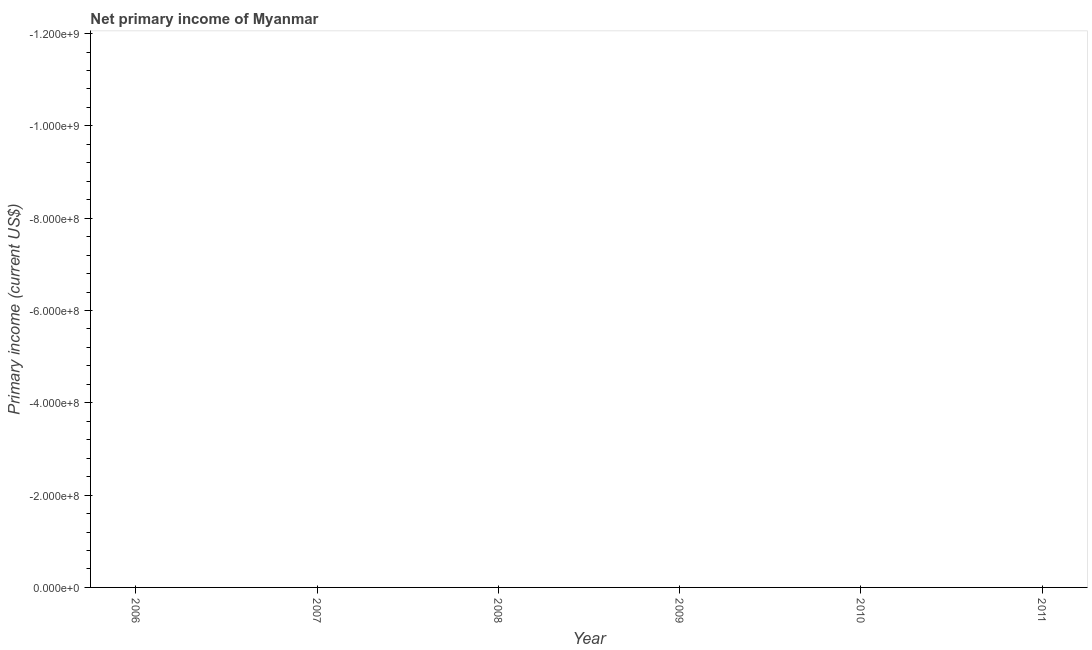What is the average amount of primary income per year?
Your answer should be compact. 0. What is the median amount of primary income?
Your answer should be compact. 0. In how many years, is the amount of primary income greater than -360000000 US$?
Provide a succinct answer. 0. In how many years, is the amount of primary income greater than the average amount of primary income taken over all years?
Provide a succinct answer. 0. Does the amount of primary income monotonically increase over the years?
Provide a succinct answer. No. How many lines are there?
Your answer should be compact. 0. Does the graph contain any zero values?
Give a very brief answer. Yes. What is the title of the graph?
Your response must be concise. Net primary income of Myanmar. What is the label or title of the Y-axis?
Provide a succinct answer. Primary income (current US$). What is the Primary income (current US$) in 2008?
Your response must be concise. 0. What is the Primary income (current US$) in 2010?
Offer a very short reply. 0. What is the Primary income (current US$) of 2011?
Ensure brevity in your answer.  0. 